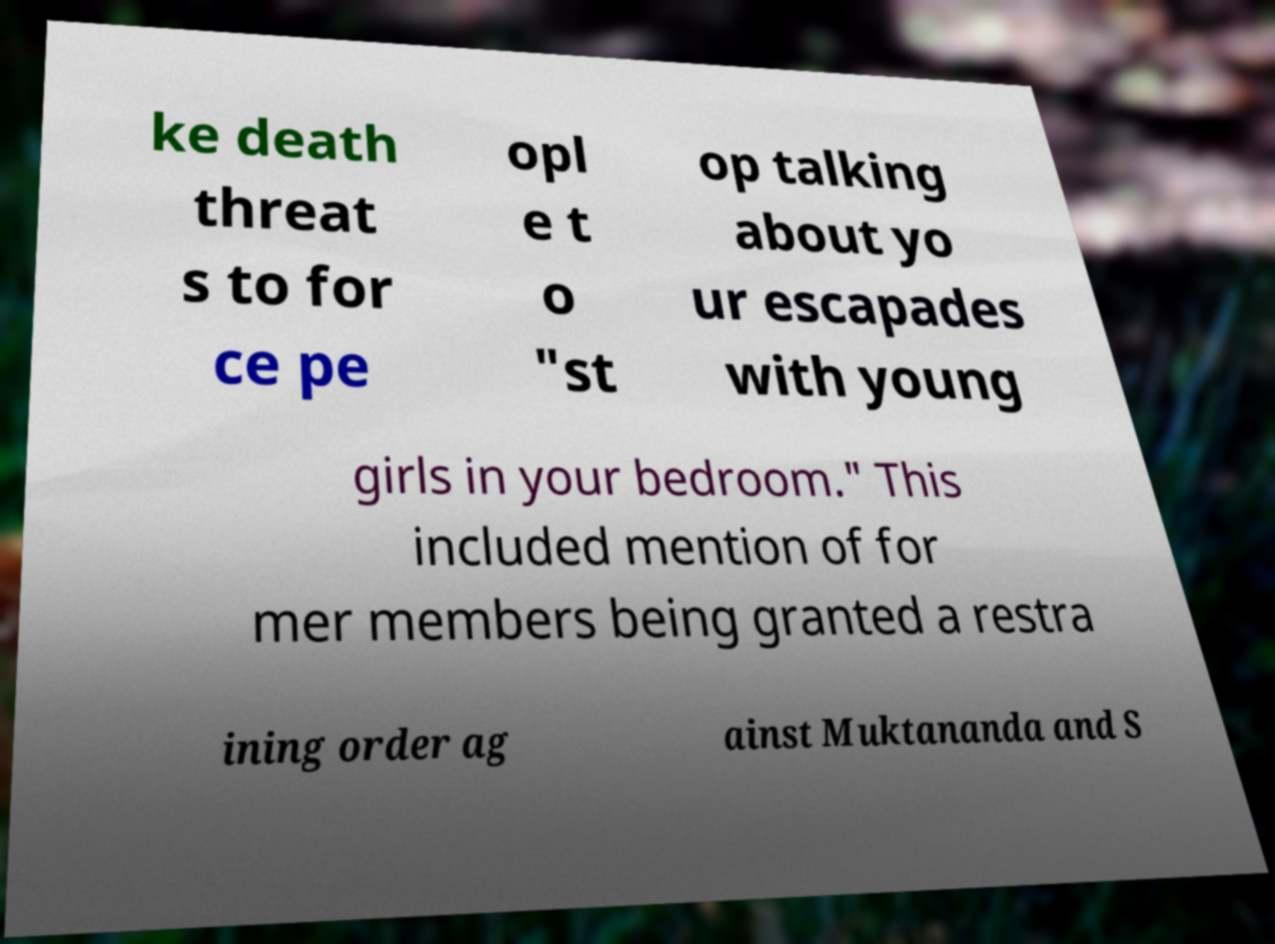What messages or text are displayed in this image? I need them in a readable, typed format. ke death threat s to for ce pe opl e t o "st op talking about yo ur escapades with young girls in your bedroom." This included mention of for mer members being granted a restra ining order ag ainst Muktananda and S 